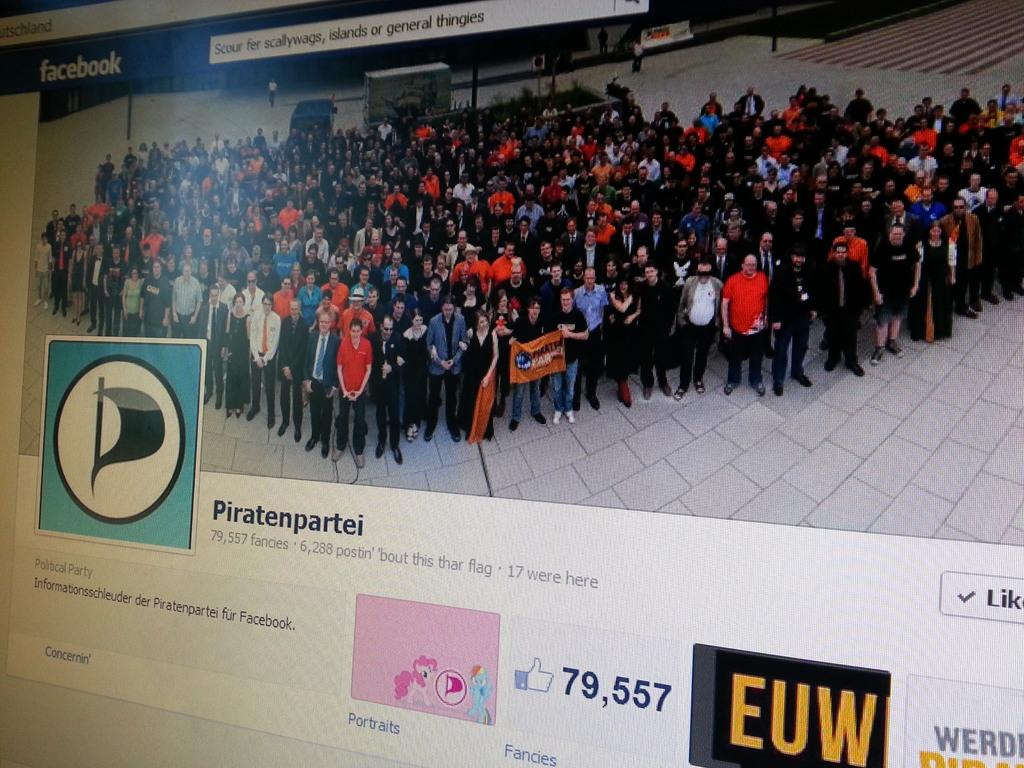<image>
Relay a brief, clear account of the picture shown. A computer screen open to a facebook page showing a large group of people. 